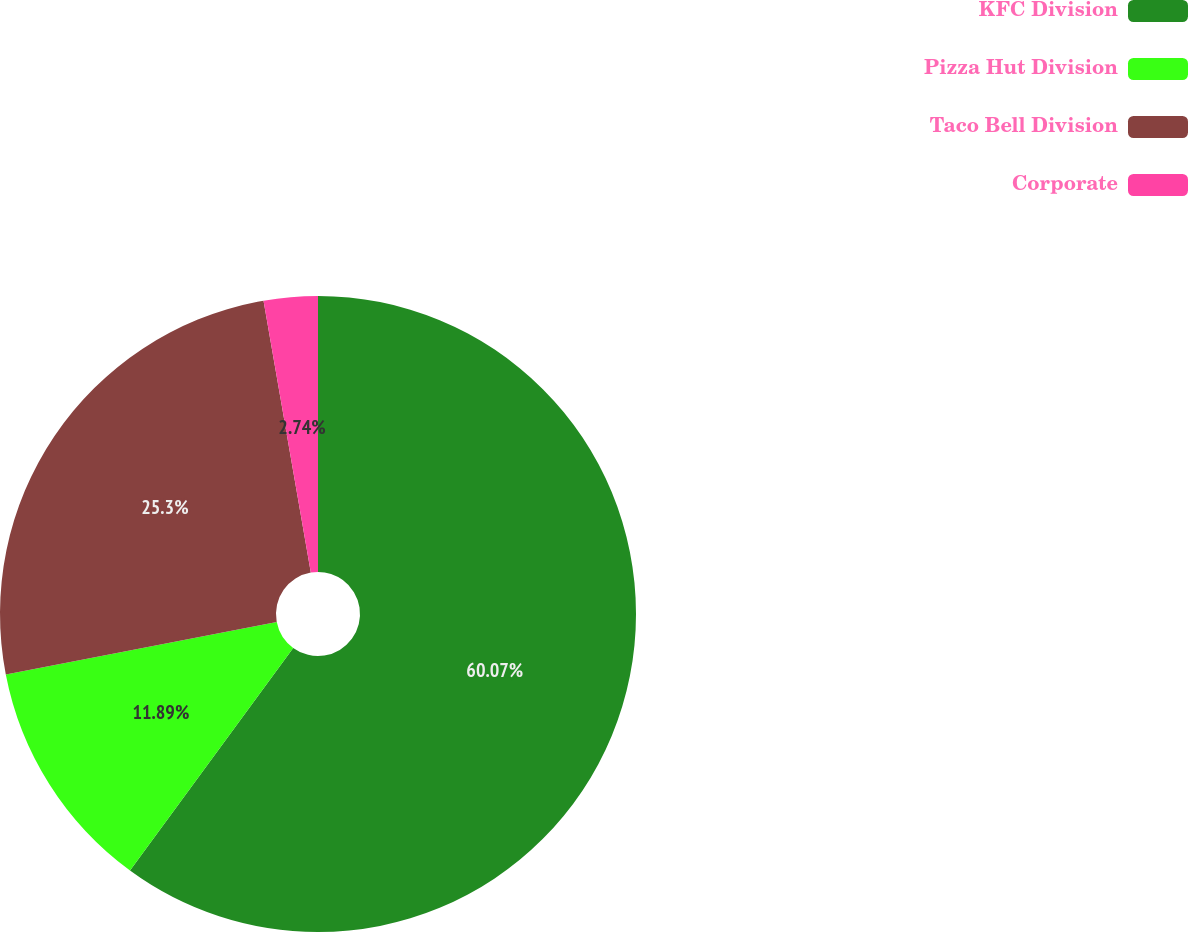Convert chart to OTSL. <chart><loc_0><loc_0><loc_500><loc_500><pie_chart><fcel>KFC Division<fcel>Pizza Hut Division<fcel>Taco Bell Division<fcel>Corporate<nl><fcel>60.06%<fcel>11.89%<fcel>25.3%<fcel>2.74%<nl></chart> 